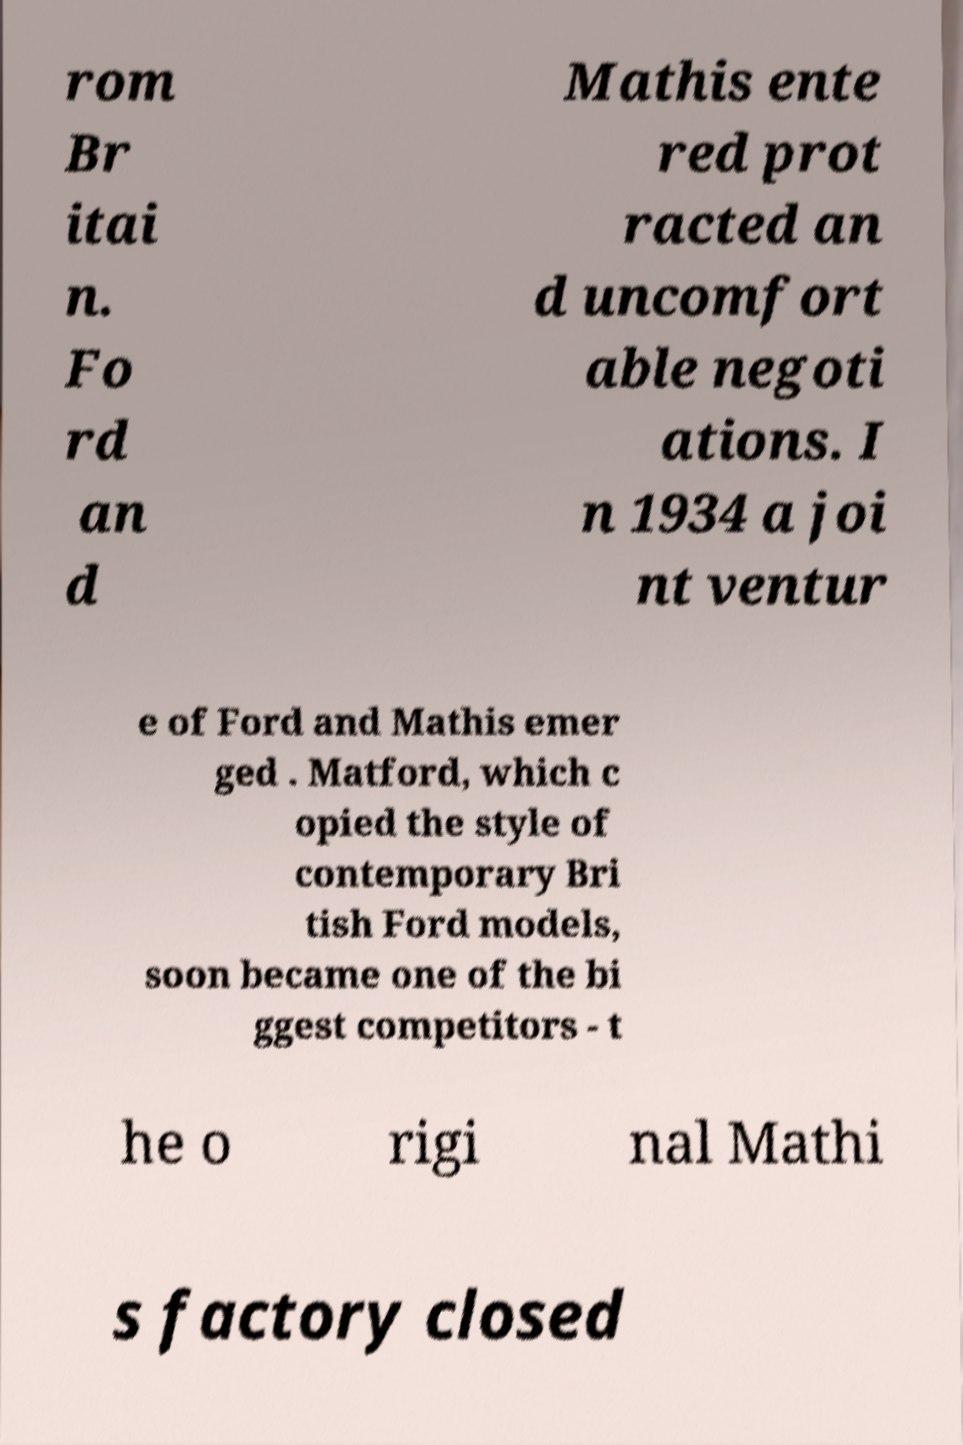Could you assist in decoding the text presented in this image and type it out clearly? rom Br itai n. Fo rd an d Mathis ente red prot racted an d uncomfort able negoti ations. I n 1934 a joi nt ventur e of Ford and Mathis emer ged . Matford, which c opied the style of contemporary Bri tish Ford models, soon became one of the bi ggest competitors - t he o rigi nal Mathi s factory closed 